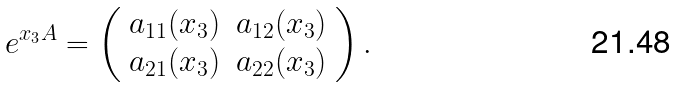Convert formula to latex. <formula><loc_0><loc_0><loc_500><loc_500>e ^ { { x _ { 3 } } A } = \left ( \begin{array} { c r } a _ { 1 1 } ( { x _ { 3 } } ) & a _ { 1 2 } ( { x _ { 3 } } ) \\ a _ { 2 1 } ( { x _ { 3 } } ) & a _ { 2 2 } ( { x _ { 3 } } ) \end{array} \right ) .</formula> 